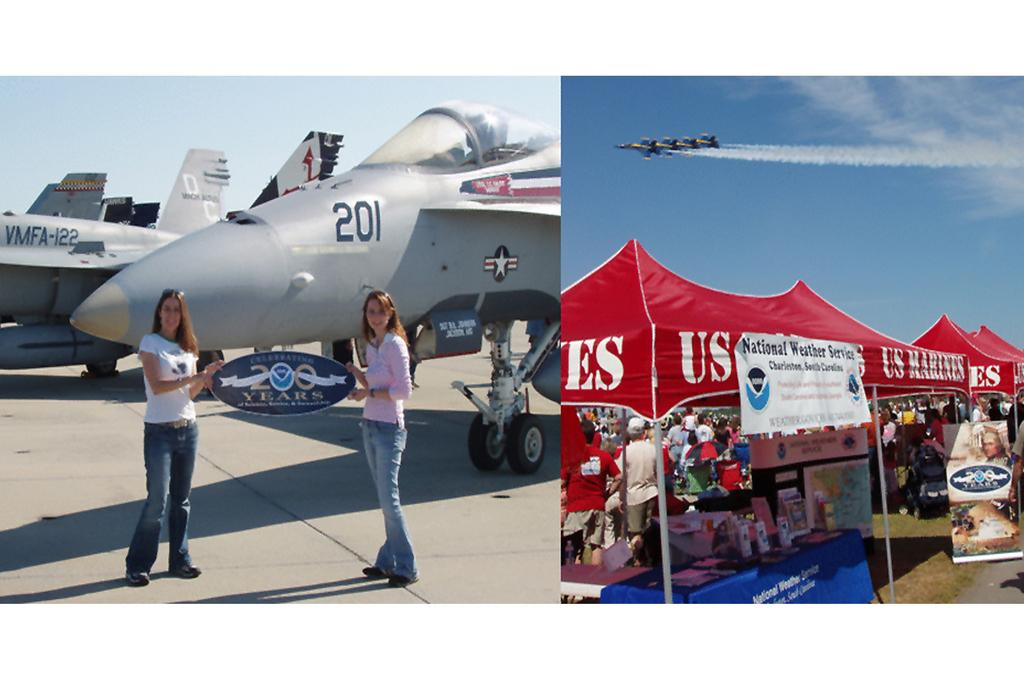<image>
Render a clear and concise summary of the photo. At an airshow, people pose in front of jet 201 and the U.S. Marines have an awning set up. 